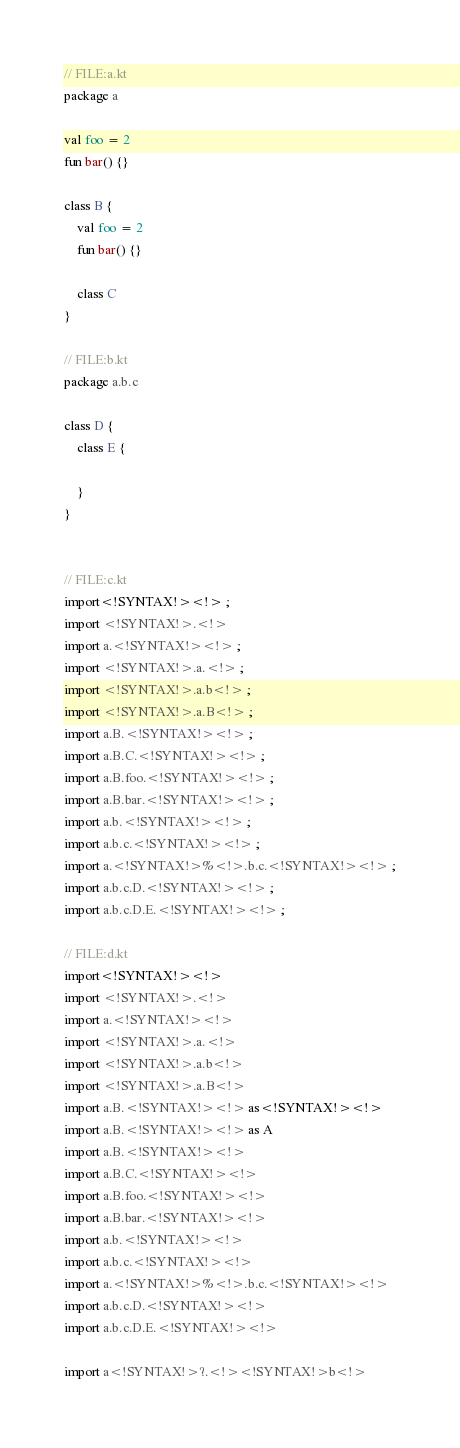<code> <loc_0><loc_0><loc_500><loc_500><_Kotlin_>// FILE:a.kt
package a

val foo = 2
fun bar() {}

class B {
    val foo = 2
    fun bar() {}

    class C
}

// FILE:b.kt
package a.b.c

class D {
    class E {

    }
}


// FILE:c.kt
import<!SYNTAX!><!> ;
import <!SYNTAX!>.<!>
import a.<!SYNTAX!><!> ;
import <!SYNTAX!>.a.<!> ;
import <!SYNTAX!>.a.b<!> ;
import <!SYNTAX!>.a.B<!> ;
import a.B.<!SYNTAX!><!> ;
import a.B.C.<!SYNTAX!><!> ;
import a.B.foo.<!SYNTAX!><!> ;
import a.B.bar.<!SYNTAX!><!> ;
import a.b.<!SYNTAX!><!> ;
import a.b.c.<!SYNTAX!><!> ;
import a.<!SYNTAX!>%<!>.b.c.<!SYNTAX!><!> ;
import a.b.c.D.<!SYNTAX!><!> ;
import a.b.c.D.E.<!SYNTAX!><!> ;

// FILE:d.kt
import<!SYNTAX!><!>
import <!SYNTAX!>.<!>
import a.<!SYNTAX!><!>
import <!SYNTAX!>.a.<!>
import <!SYNTAX!>.a.b<!>
import <!SYNTAX!>.a.B<!>
import a.B.<!SYNTAX!><!> as<!SYNTAX!><!>
import a.B.<!SYNTAX!><!> as A
import a.B.<!SYNTAX!><!>
import a.B.C.<!SYNTAX!><!>
import a.B.foo.<!SYNTAX!><!>
import a.B.bar.<!SYNTAX!><!>
import a.b.<!SYNTAX!><!>
import a.b.c.<!SYNTAX!><!>
import a.<!SYNTAX!>%<!>.b.c.<!SYNTAX!><!>
import a.b.c.D.<!SYNTAX!><!>
import a.b.c.D.E.<!SYNTAX!><!>

import a<!SYNTAX!>?.<!><!SYNTAX!>b<!></code> 